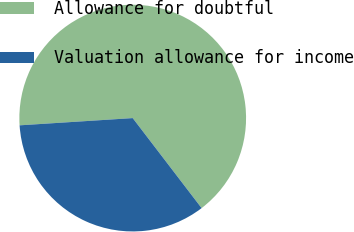<chart> <loc_0><loc_0><loc_500><loc_500><pie_chart><fcel>Allowance for doubtful<fcel>Valuation allowance for income<nl><fcel>65.62%<fcel>34.38%<nl></chart> 